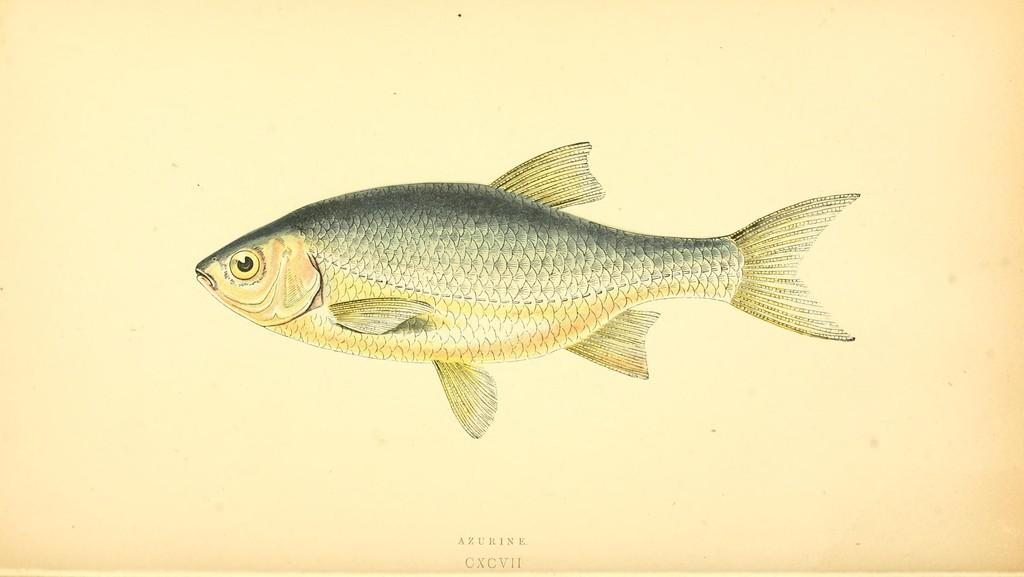What is the main subject of the painting in the image? The painting in the image depicts a fish. What are some features of the fish in the painting? The fish has fins, gills, eyes, and a tail. Can you describe the color or shading in the painting? There is some black shade on the painting. What type of mint is growing on the fish's back in the painting? There is no mint or any plant life depicted on the fish's back in the painting. What is the reason behind the fish having a black shade in the painting? The facts provided do not mention a reason for the black shade in the painting, so we cannot determine the reason behind it. 